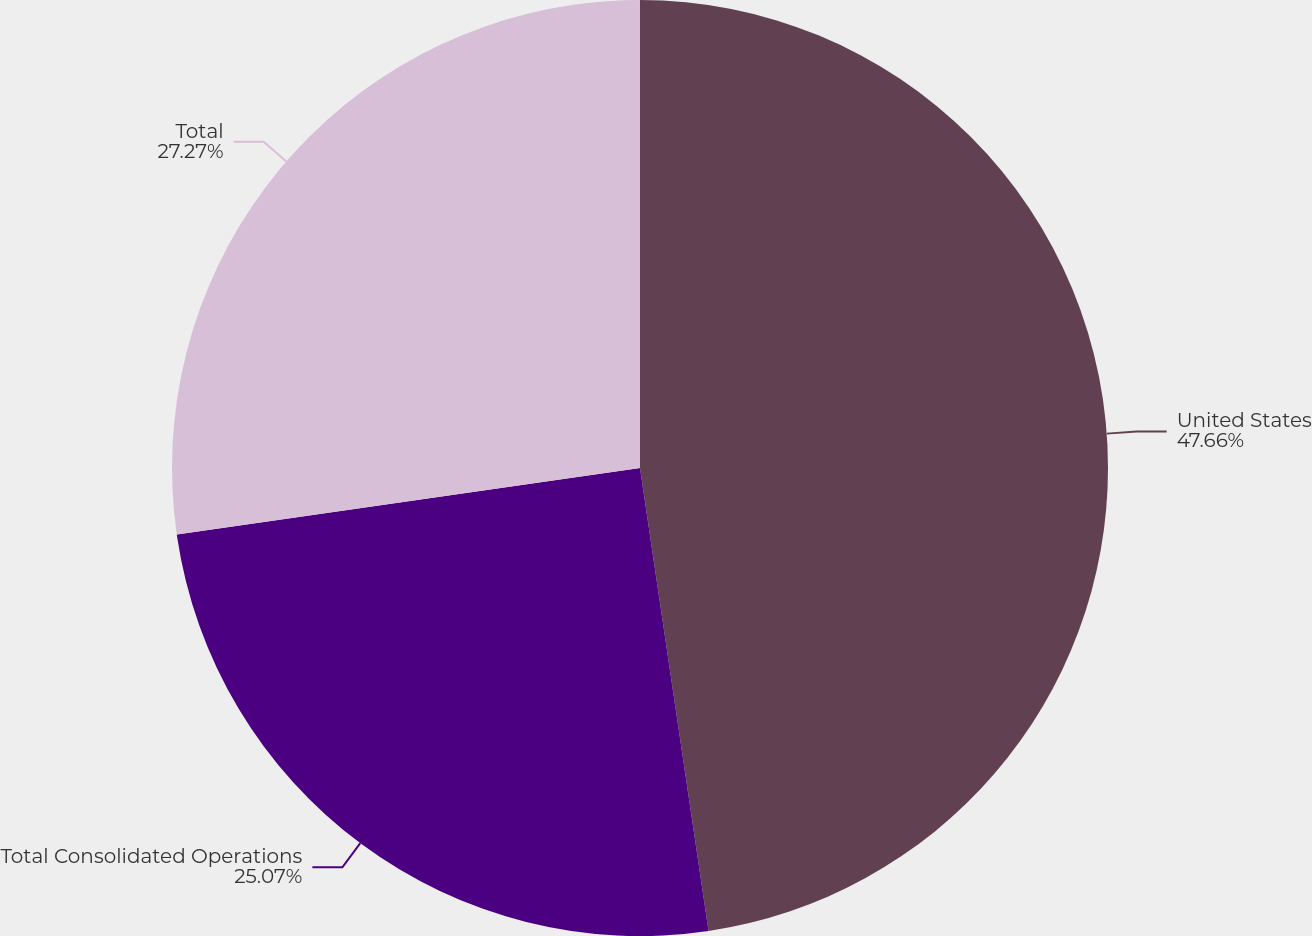<chart> <loc_0><loc_0><loc_500><loc_500><pie_chart><fcel>United States<fcel>Total Consolidated Operations<fcel>Total<nl><fcel>47.66%<fcel>25.07%<fcel>27.27%<nl></chart> 